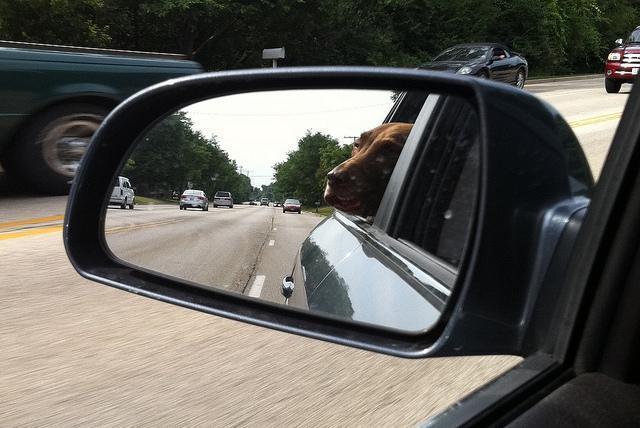How many cars are there?
Give a very brief answer. 2. 